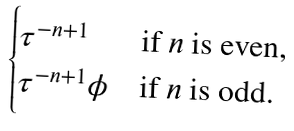<formula> <loc_0><loc_0><loc_500><loc_500>\begin{cases} \tau ^ { - n + 1 } & \text {if $n$ is even,} \\ \tau ^ { - n + 1 } \phi & \text {if $n$ is odd.} \end{cases}</formula> 